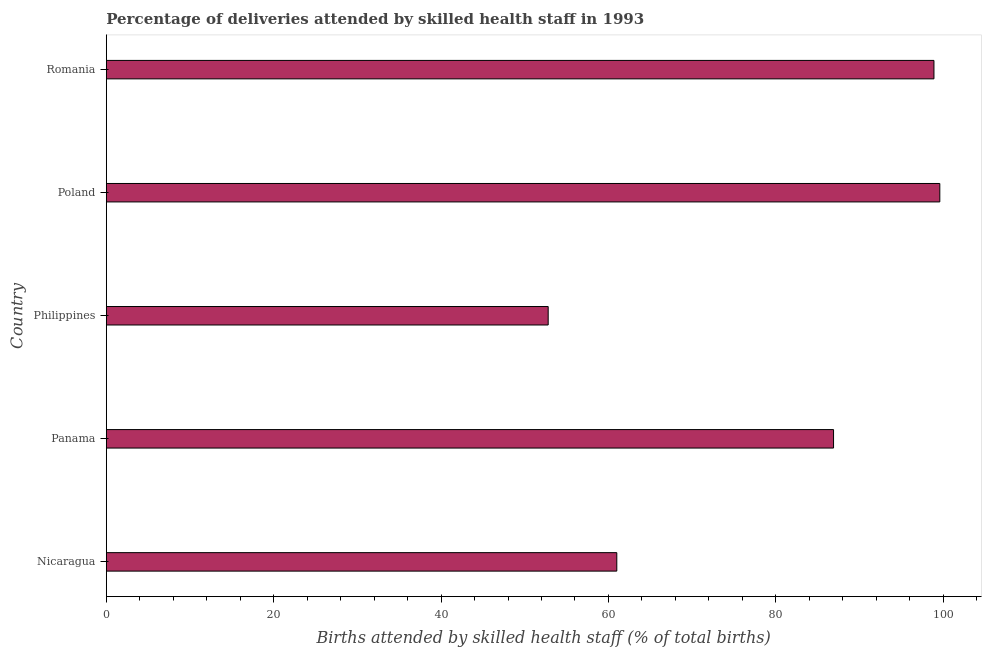Does the graph contain any zero values?
Your response must be concise. No. What is the title of the graph?
Ensure brevity in your answer.  Percentage of deliveries attended by skilled health staff in 1993. What is the label or title of the X-axis?
Provide a short and direct response. Births attended by skilled health staff (% of total births). What is the label or title of the Y-axis?
Ensure brevity in your answer.  Country. What is the number of births attended by skilled health staff in Romania?
Ensure brevity in your answer.  98.9. Across all countries, what is the maximum number of births attended by skilled health staff?
Keep it short and to the point. 99.6. Across all countries, what is the minimum number of births attended by skilled health staff?
Your answer should be compact. 52.8. In which country was the number of births attended by skilled health staff maximum?
Your response must be concise. Poland. What is the sum of the number of births attended by skilled health staff?
Give a very brief answer. 399.2. What is the difference between the number of births attended by skilled health staff in Nicaragua and Romania?
Your answer should be compact. -37.9. What is the average number of births attended by skilled health staff per country?
Keep it short and to the point. 79.84. What is the median number of births attended by skilled health staff?
Make the answer very short. 86.9. In how many countries, is the number of births attended by skilled health staff greater than 44 %?
Make the answer very short. 5. What is the ratio of the number of births attended by skilled health staff in Philippines to that in Romania?
Provide a succinct answer. 0.53. Is the difference between the number of births attended by skilled health staff in Poland and Romania greater than the difference between any two countries?
Ensure brevity in your answer.  No. What is the difference between the highest and the lowest number of births attended by skilled health staff?
Your response must be concise. 46.8. In how many countries, is the number of births attended by skilled health staff greater than the average number of births attended by skilled health staff taken over all countries?
Keep it short and to the point. 3. Are all the bars in the graph horizontal?
Ensure brevity in your answer.  Yes. How many countries are there in the graph?
Offer a terse response. 5. Are the values on the major ticks of X-axis written in scientific E-notation?
Give a very brief answer. No. What is the Births attended by skilled health staff (% of total births) in Panama?
Keep it short and to the point. 86.9. What is the Births attended by skilled health staff (% of total births) in Philippines?
Ensure brevity in your answer.  52.8. What is the Births attended by skilled health staff (% of total births) in Poland?
Your answer should be compact. 99.6. What is the Births attended by skilled health staff (% of total births) in Romania?
Ensure brevity in your answer.  98.9. What is the difference between the Births attended by skilled health staff (% of total births) in Nicaragua and Panama?
Your answer should be very brief. -25.9. What is the difference between the Births attended by skilled health staff (% of total births) in Nicaragua and Poland?
Offer a terse response. -38.6. What is the difference between the Births attended by skilled health staff (% of total births) in Nicaragua and Romania?
Provide a short and direct response. -37.9. What is the difference between the Births attended by skilled health staff (% of total births) in Panama and Philippines?
Provide a succinct answer. 34.1. What is the difference between the Births attended by skilled health staff (% of total births) in Panama and Romania?
Keep it short and to the point. -12. What is the difference between the Births attended by skilled health staff (% of total births) in Philippines and Poland?
Provide a short and direct response. -46.8. What is the difference between the Births attended by skilled health staff (% of total births) in Philippines and Romania?
Give a very brief answer. -46.1. What is the difference between the Births attended by skilled health staff (% of total births) in Poland and Romania?
Provide a succinct answer. 0.7. What is the ratio of the Births attended by skilled health staff (% of total births) in Nicaragua to that in Panama?
Make the answer very short. 0.7. What is the ratio of the Births attended by skilled health staff (% of total births) in Nicaragua to that in Philippines?
Keep it short and to the point. 1.16. What is the ratio of the Births attended by skilled health staff (% of total births) in Nicaragua to that in Poland?
Give a very brief answer. 0.61. What is the ratio of the Births attended by skilled health staff (% of total births) in Nicaragua to that in Romania?
Your answer should be very brief. 0.62. What is the ratio of the Births attended by skilled health staff (% of total births) in Panama to that in Philippines?
Make the answer very short. 1.65. What is the ratio of the Births attended by skilled health staff (% of total births) in Panama to that in Poland?
Your response must be concise. 0.87. What is the ratio of the Births attended by skilled health staff (% of total births) in Panama to that in Romania?
Offer a terse response. 0.88. What is the ratio of the Births attended by skilled health staff (% of total births) in Philippines to that in Poland?
Give a very brief answer. 0.53. What is the ratio of the Births attended by skilled health staff (% of total births) in Philippines to that in Romania?
Offer a very short reply. 0.53. What is the ratio of the Births attended by skilled health staff (% of total births) in Poland to that in Romania?
Offer a very short reply. 1.01. 